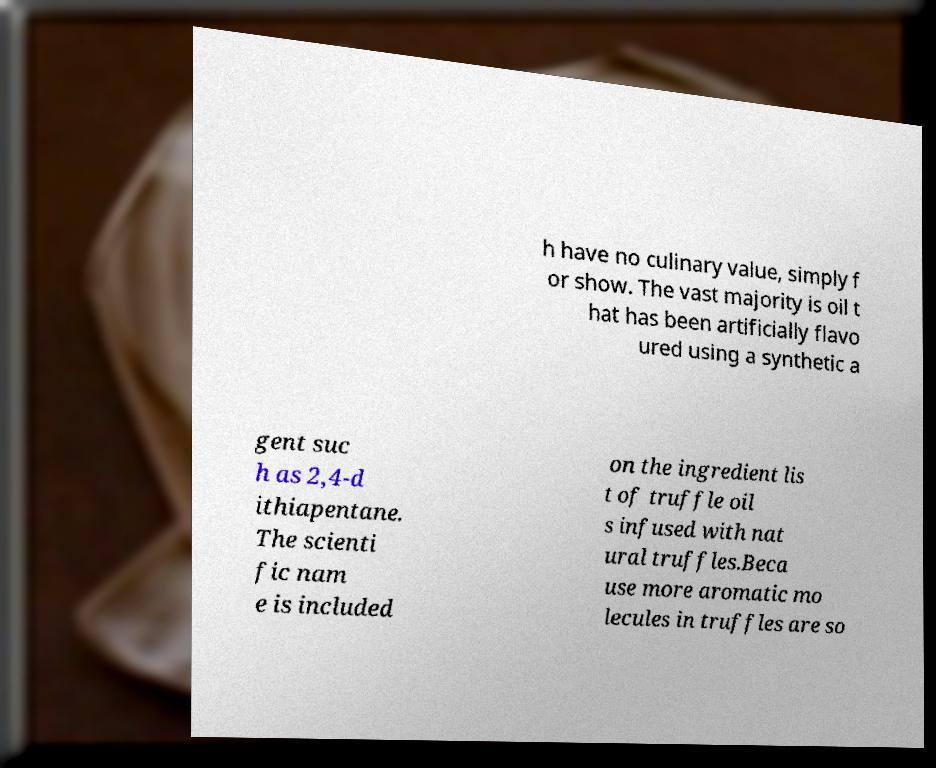For documentation purposes, I need the text within this image transcribed. Could you provide that? h have no culinary value, simply f or show. The vast majority is oil t hat has been artificially flavo ured using a synthetic a gent suc h as 2,4-d ithiapentane. The scienti fic nam e is included on the ingredient lis t of truffle oil s infused with nat ural truffles.Beca use more aromatic mo lecules in truffles are so 